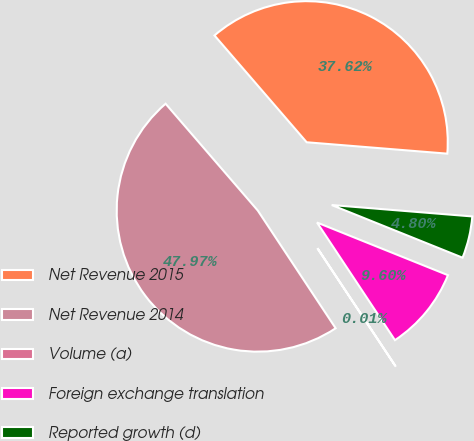<chart> <loc_0><loc_0><loc_500><loc_500><pie_chart><fcel>Net Revenue 2015<fcel>Net Revenue 2014<fcel>Volume (a)<fcel>Foreign exchange translation<fcel>Reported growth (d)<nl><fcel>37.62%<fcel>47.97%<fcel>0.01%<fcel>9.6%<fcel>4.8%<nl></chart> 